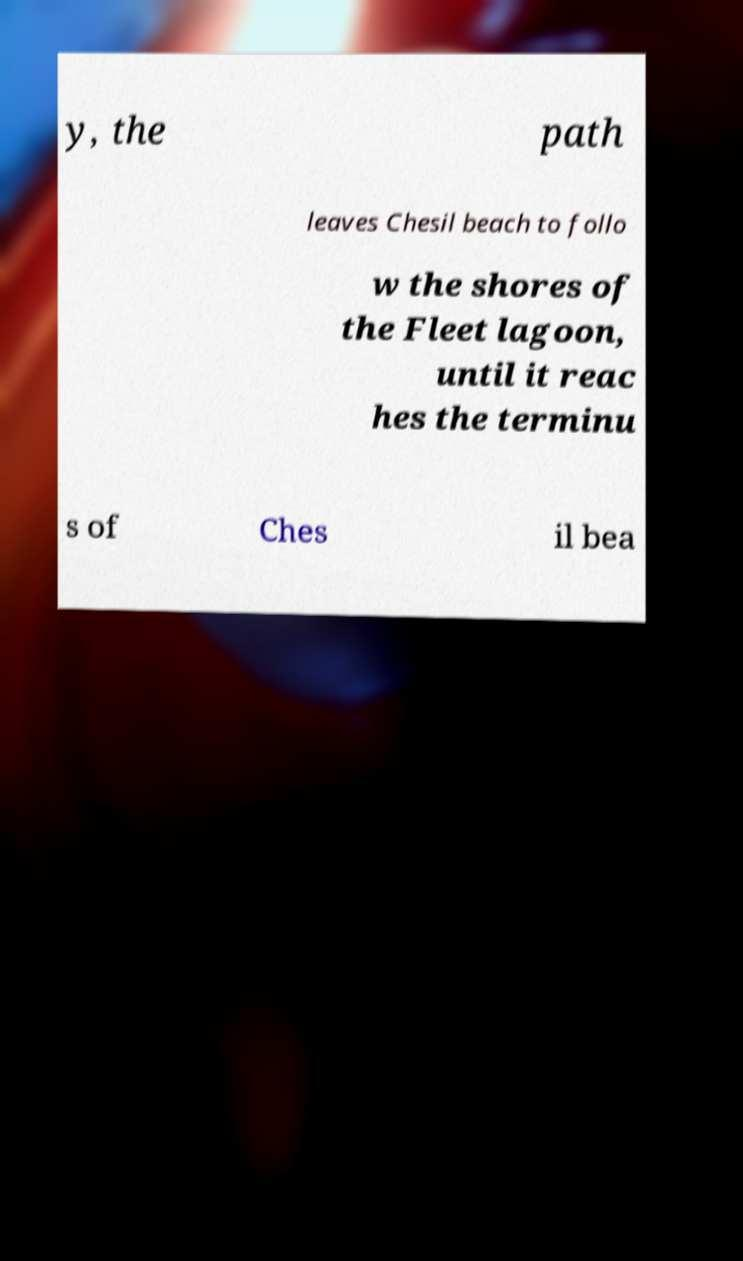What messages or text are displayed in this image? I need them in a readable, typed format. y, the path leaves Chesil beach to follo w the shores of the Fleet lagoon, until it reac hes the terminu s of Ches il bea 